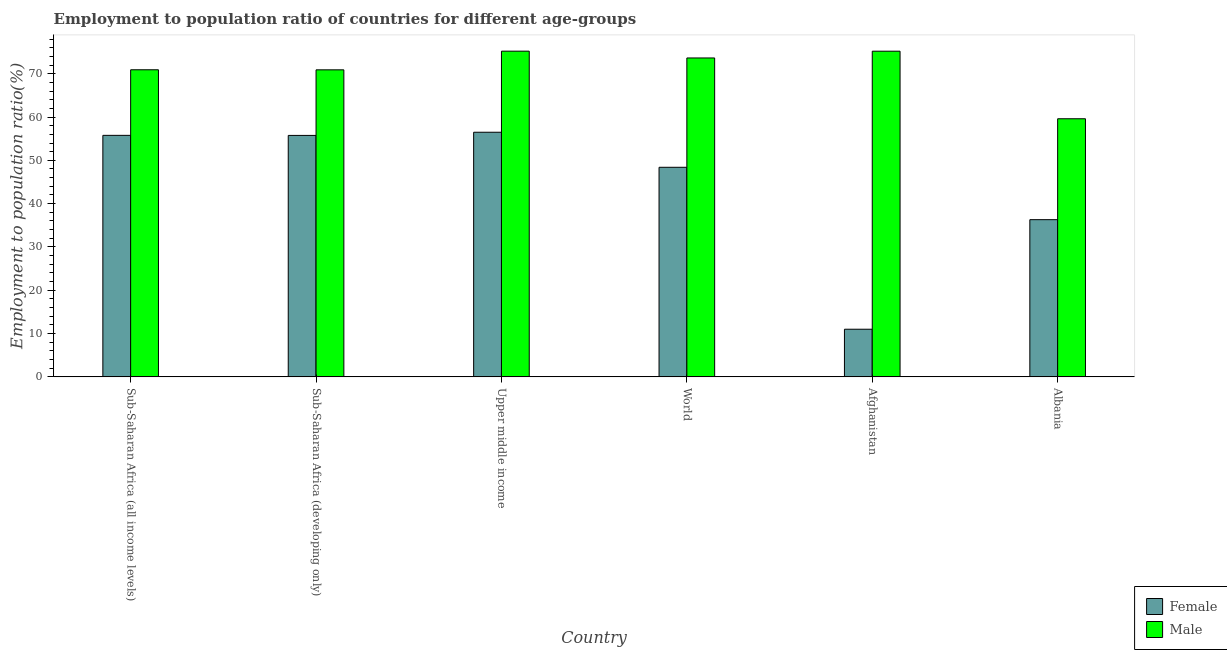How many different coloured bars are there?
Offer a very short reply. 2. Are the number of bars per tick equal to the number of legend labels?
Keep it short and to the point. Yes. Are the number of bars on each tick of the X-axis equal?
Make the answer very short. Yes. How many bars are there on the 6th tick from the right?
Ensure brevity in your answer.  2. What is the label of the 5th group of bars from the left?
Your response must be concise. Afghanistan. What is the employment to population ratio(male) in Sub-Saharan Africa (developing only)?
Provide a succinct answer. 70.89. Across all countries, what is the maximum employment to population ratio(male)?
Offer a very short reply. 75.21. Across all countries, what is the minimum employment to population ratio(female)?
Your response must be concise. 11. In which country was the employment to population ratio(female) maximum?
Your answer should be compact. Upper middle income. In which country was the employment to population ratio(male) minimum?
Give a very brief answer. Albania. What is the total employment to population ratio(male) in the graph?
Give a very brief answer. 425.45. What is the difference between the employment to population ratio(male) in Sub-Saharan Africa (developing only) and that in World?
Offer a very short reply. -2.74. What is the difference between the employment to population ratio(female) in Sub-Saharan Africa (developing only) and the employment to population ratio(male) in Upper middle income?
Give a very brief answer. -19.46. What is the average employment to population ratio(male) per country?
Your answer should be compact. 70.91. What is the difference between the employment to population ratio(female) and employment to population ratio(male) in Afghanistan?
Your answer should be very brief. -64.2. What is the ratio of the employment to population ratio(female) in Albania to that in World?
Ensure brevity in your answer.  0.75. Is the employment to population ratio(male) in Afghanistan less than that in Upper middle income?
Provide a succinct answer. Yes. What is the difference between the highest and the second highest employment to population ratio(male)?
Give a very brief answer. 0.01. What is the difference between the highest and the lowest employment to population ratio(male)?
Make the answer very short. 15.61. In how many countries, is the employment to population ratio(male) greater than the average employment to population ratio(male) taken over all countries?
Offer a terse response. 4. Is the sum of the employment to population ratio(male) in Sub-Saharan Africa (developing only) and World greater than the maximum employment to population ratio(female) across all countries?
Make the answer very short. Yes. How many bars are there?
Ensure brevity in your answer.  12. How many countries are there in the graph?
Give a very brief answer. 6. What is the difference between two consecutive major ticks on the Y-axis?
Your answer should be very brief. 10. Does the graph contain grids?
Your answer should be compact. No. Where does the legend appear in the graph?
Offer a terse response. Bottom right. What is the title of the graph?
Your answer should be compact. Employment to population ratio of countries for different age-groups. What is the label or title of the Y-axis?
Your answer should be compact. Employment to population ratio(%). What is the Employment to population ratio(%) in Female in Sub-Saharan Africa (all income levels)?
Your response must be concise. 55.77. What is the Employment to population ratio(%) in Male in Sub-Saharan Africa (all income levels)?
Keep it short and to the point. 70.91. What is the Employment to population ratio(%) of Female in Sub-Saharan Africa (developing only)?
Ensure brevity in your answer.  55.75. What is the Employment to population ratio(%) of Male in Sub-Saharan Africa (developing only)?
Your response must be concise. 70.89. What is the Employment to population ratio(%) in Female in Upper middle income?
Keep it short and to the point. 56.48. What is the Employment to population ratio(%) in Male in Upper middle income?
Keep it short and to the point. 75.21. What is the Employment to population ratio(%) of Female in World?
Ensure brevity in your answer.  48.39. What is the Employment to population ratio(%) in Male in World?
Provide a succinct answer. 73.64. What is the Employment to population ratio(%) in Male in Afghanistan?
Your answer should be very brief. 75.2. What is the Employment to population ratio(%) in Female in Albania?
Ensure brevity in your answer.  36.3. What is the Employment to population ratio(%) of Male in Albania?
Ensure brevity in your answer.  59.6. Across all countries, what is the maximum Employment to population ratio(%) in Female?
Your answer should be very brief. 56.48. Across all countries, what is the maximum Employment to population ratio(%) in Male?
Keep it short and to the point. 75.21. Across all countries, what is the minimum Employment to population ratio(%) of Male?
Make the answer very short. 59.6. What is the total Employment to population ratio(%) in Female in the graph?
Keep it short and to the point. 263.7. What is the total Employment to population ratio(%) in Male in the graph?
Provide a short and direct response. 425.45. What is the difference between the Employment to population ratio(%) of Female in Sub-Saharan Africa (all income levels) and that in Sub-Saharan Africa (developing only)?
Provide a succinct answer. 0.02. What is the difference between the Employment to population ratio(%) in Male in Sub-Saharan Africa (all income levels) and that in Sub-Saharan Africa (developing only)?
Your answer should be very brief. 0.01. What is the difference between the Employment to population ratio(%) of Female in Sub-Saharan Africa (all income levels) and that in Upper middle income?
Your answer should be very brief. -0.72. What is the difference between the Employment to population ratio(%) of Male in Sub-Saharan Africa (all income levels) and that in Upper middle income?
Provide a succinct answer. -4.3. What is the difference between the Employment to population ratio(%) in Female in Sub-Saharan Africa (all income levels) and that in World?
Ensure brevity in your answer.  7.37. What is the difference between the Employment to population ratio(%) of Male in Sub-Saharan Africa (all income levels) and that in World?
Ensure brevity in your answer.  -2.73. What is the difference between the Employment to population ratio(%) in Female in Sub-Saharan Africa (all income levels) and that in Afghanistan?
Ensure brevity in your answer.  44.77. What is the difference between the Employment to population ratio(%) of Male in Sub-Saharan Africa (all income levels) and that in Afghanistan?
Offer a very short reply. -4.29. What is the difference between the Employment to population ratio(%) of Female in Sub-Saharan Africa (all income levels) and that in Albania?
Make the answer very short. 19.47. What is the difference between the Employment to population ratio(%) of Male in Sub-Saharan Africa (all income levels) and that in Albania?
Your answer should be very brief. 11.31. What is the difference between the Employment to population ratio(%) in Female in Sub-Saharan Africa (developing only) and that in Upper middle income?
Keep it short and to the point. -0.73. What is the difference between the Employment to population ratio(%) of Male in Sub-Saharan Africa (developing only) and that in Upper middle income?
Provide a succinct answer. -4.31. What is the difference between the Employment to population ratio(%) of Female in Sub-Saharan Africa (developing only) and that in World?
Make the answer very short. 7.36. What is the difference between the Employment to population ratio(%) in Male in Sub-Saharan Africa (developing only) and that in World?
Give a very brief answer. -2.74. What is the difference between the Employment to population ratio(%) of Female in Sub-Saharan Africa (developing only) and that in Afghanistan?
Your answer should be very brief. 44.75. What is the difference between the Employment to population ratio(%) of Male in Sub-Saharan Africa (developing only) and that in Afghanistan?
Give a very brief answer. -4.31. What is the difference between the Employment to population ratio(%) of Female in Sub-Saharan Africa (developing only) and that in Albania?
Offer a very short reply. 19.45. What is the difference between the Employment to population ratio(%) in Male in Sub-Saharan Africa (developing only) and that in Albania?
Give a very brief answer. 11.29. What is the difference between the Employment to population ratio(%) in Female in Upper middle income and that in World?
Provide a short and direct response. 8.09. What is the difference between the Employment to population ratio(%) of Male in Upper middle income and that in World?
Offer a very short reply. 1.57. What is the difference between the Employment to population ratio(%) in Female in Upper middle income and that in Afghanistan?
Offer a very short reply. 45.48. What is the difference between the Employment to population ratio(%) of Male in Upper middle income and that in Afghanistan?
Provide a succinct answer. 0.01. What is the difference between the Employment to population ratio(%) in Female in Upper middle income and that in Albania?
Your response must be concise. 20.18. What is the difference between the Employment to population ratio(%) of Male in Upper middle income and that in Albania?
Ensure brevity in your answer.  15.61. What is the difference between the Employment to population ratio(%) of Female in World and that in Afghanistan?
Keep it short and to the point. 37.39. What is the difference between the Employment to population ratio(%) in Male in World and that in Afghanistan?
Your response must be concise. -1.56. What is the difference between the Employment to population ratio(%) of Female in World and that in Albania?
Ensure brevity in your answer.  12.09. What is the difference between the Employment to population ratio(%) of Male in World and that in Albania?
Provide a succinct answer. 14.04. What is the difference between the Employment to population ratio(%) of Female in Afghanistan and that in Albania?
Ensure brevity in your answer.  -25.3. What is the difference between the Employment to population ratio(%) in Male in Afghanistan and that in Albania?
Your answer should be very brief. 15.6. What is the difference between the Employment to population ratio(%) of Female in Sub-Saharan Africa (all income levels) and the Employment to population ratio(%) of Male in Sub-Saharan Africa (developing only)?
Make the answer very short. -15.13. What is the difference between the Employment to population ratio(%) of Female in Sub-Saharan Africa (all income levels) and the Employment to population ratio(%) of Male in Upper middle income?
Provide a succinct answer. -19.44. What is the difference between the Employment to population ratio(%) in Female in Sub-Saharan Africa (all income levels) and the Employment to population ratio(%) in Male in World?
Ensure brevity in your answer.  -17.87. What is the difference between the Employment to population ratio(%) of Female in Sub-Saharan Africa (all income levels) and the Employment to population ratio(%) of Male in Afghanistan?
Your answer should be compact. -19.43. What is the difference between the Employment to population ratio(%) in Female in Sub-Saharan Africa (all income levels) and the Employment to population ratio(%) in Male in Albania?
Offer a very short reply. -3.83. What is the difference between the Employment to population ratio(%) in Female in Sub-Saharan Africa (developing only) and the Employment to population ratio(%) in Male in Upper middle income?
Your response must be concise. -19.46. What is the difference between the Employment to population ratio(%) of Female in Sub-Saharan Africa (developing only) and the Employment to population ratio(%) of Male in World?
Your answer should be very brief. -17.89. What is the difference between the Employment to population ratio(%) of Female in Sub-Saharan Africa (developing only) and the Employment to population ratio(%) of Male in Afghanistan?
Your answer should be compact. -19.45. What is the difference between the Employment to population ratio(%) of Female in Sub-Saharan Africa (developing only) and the Employment to population ratio(%) of Male in Albania?
Your response must be concise. -3.85. What is the difference between the Employment to population ratio(%) in Female in Upper middle income and the Employment to population ratio(%) in Male in World?
Provide a short and direct response. -17.15. What is the difference between the Employment to population ratio(%) of Female in Upper middle income and the Employment to population ratio(%) of Male in Afghanistan?
Keep it short and to the point. -18.72. What is the difference between the Employment to population ratio(%) in Female in Upper middle income and the Employment to population ratio(%) in Male in Albania?
Offer a very short reply. -3.12. What is the difference between the Employment to population ratio(%) in Female in World and the Employment to population ratio(%) in Male in Afghanistan?
Your answer should be compact. -26.81. What is the difference between the Employment to population ratio(%) of Female in World and the Employment to population ratio(%) of Male in Albania?
Offer a terse response. -11.21. What is the difference between the Employment to population ratio(%) in Female in Afghanistan and the Employment to population ratio(%) in Male in Albania?
Keep it short and to the point. -48.6. What is the average Employment to population ratio(%) in Female per country?
Ensure brevity in your answer.  43.95. What is the average Employment to population ratio(%) of Male per country?
Make the answer very short. 70.91. What is the difference between the Employment to population ratio(%) in Female and Employment to population ratio(%) in Male in Sub-Saharan Africa (all income levels)?
Provide a short and direct response. -15.14. What is the difference between the Employment to population ratio(%) of Female and Employment to population ratio(%) of Male in Sub-Saharan Africa (developing only)?
Give a very brief answer. -15.14. What is the difference between the Employment to population ratio(%) in Female and Employment to population ratio(%) in Male in Upper middle income?
Ensure brevity in your answer.  -18.72. What is the difference between the Employment to population ratio(%) in Female and Employment to population ratio(%) in Male in World?
Keep it short and to the point. -25.24. What is the difference between the Employment to population ratio(%) in Female and Employment to population ratio(%) in Male in Afghanistan?
Provide a short and direct response. -64.2. What is the difference between the Employment to population ratio(%) of Female and Employment to population ratio(%) of Male in Albania?
Your answer should be very brief. -23.3. What is the ratio of the Employment to population ratio(%) in Female in Sub-Saharan Africa (all income levels) to that in Sub-Saharan Africa (developing only)?
Provide a short and direct response. 1. What is the ratio of the Employment to population ratio(%) in Male in Sub-Saharan Africa (all income levels) to that in Sub-Saharan Africa (developing only)?
Offer a very short reply. 1. What is the ratio of the Employment to population ratio(%) of Female in Sub-Saharan Africa (all income levels) to that in Upper middle income?
Offer a very short reply. 0.99. What is the ratio of the Employment to population ratio(%) of Male in Sub-Saharan Africa (all income levels) to that in Upper middle income?
Your answer should be very brief. 0.94. What is the ratio of the Employment to population ratio(%) in Female in Sub-Saharan Africa (all income levels) to that in World?
Offer a very short reply. 1.15. What is the ratio of the Employment to population ratio(%) of Male in Sub-Saharan Africa (all income levels) to that in World?
Your response must be concise. 0.96. What is the ratio of the Employment to population ratio(%) in Female in Sub-Saharan Africa (all income levels) to that in Afghanistan?
Give a very brief answer. 5.07. What is the ratio of the Employment to population ratio(%) in Male in Sub-Saharan Africa (all income levels) to that in Afghanistan?
Keep it short and to the point. 0.94. What is the ratio of the Employment to population ratio(%) in Female in Sub-Saharan Africa (all income levels) to that in Albania?
Ensure brevity in your answer.  1.54. What is the ratio of the Employment to population ratio(%) in Male in Sub-Saharan Africa (all income levels) to that in Albania?
Your answer should be compact. 1.19. What is the ratio of the Employment to population ratio(%) of Female in Sub-Saharan Africa (developing only) to that in Upper middle income?
Your answer should be very brief. 0.99. What is the ratio of the Employment to population ratio(%) of Male in Sub-Saharan Africa (developing only) to that in Upper middle income?
Make the answer very short. 0.94. What is the ratio of the Employment to population ratio(%) in Female in Sub-Saharan Africa (developing only) to that in World?
Your response must be concise. 1.15. What is the ratio of the Employment to population ratio(%) of Male in Sub-Saharan Africa (developing only) to that in World?
Keep it short and to the point. 0.96. What is the ratio of the Employment to population ratio(%) in Female in Sub-Saharan Africa (developing only) to that in Afghanistan?
Ensure brevity in your answer.  5.07. What is the ratio of the Employment to population ratio(%) in Male in Sub-Saharan Africa (developing only) to that in Afghanistan?
Ensure brevity in your answer.  0.94. What is the ratio of the Employment to population ratio(%) in Female in Sub-Saharan Africa (developing only) to that in Albania?
Provide a succinct answer. 1.54. What is the ratio of the Employment to population ratio(%) in Male in Sub-Saharan Africa (developing only) to that in Albania?
Your answer should be compact. 1.19. What is the ratio of the Employment to population ratio(%) in Female in Upper middle income to that in World?
Provide a short and direct response. 1.17. What is the ratio of the Employment to population ratio(%) of Male in Upper middle income to that in World?
Provide a succinct answer. 1.02. What is the ratio of the Employment to population ratio(%) in Female in Upper middle income to that in Afghanistan?
Your answer should be very brief. 5.13. What is the ratio of the Employment to population ratio(%) in Female in Upper middle income to that in Albania?
Make the answer very short. 1.56. What is the ratio of the Employment to population ratio(%) in Male in Upper middle income to that in Albania?
Give a very brief answer. 1.26. What is the ratio of the Employment to population ratio(%) of Female in World to that in Afghanistan?
Offer a very short reply. 4.4. What is the ratio of the Employment to population ratio(%) in Male in World to that in Afghanistan?
Offer a very short reply. 0.98. What is the ratio of the Employment to population ratio(%) of Female in World to that in Albania?
Make the answer very short. 1.33. What is the ratio of the Employment to population ratio(%) of Male in World to that in Albania?
Make the answer very short. 1.24. What is the ratio of the Employment to population ratio(%) in Female in Afghanistan to that in Albania?
Your answer should be compact. 0.3. What is the ratio of the Employment to population ratio(%) of Male in Afghanistan to that in Albania?
Provide a succinct answer. 1.26. What is the difference between the highest and the second highest Employment to population ratio(%) in Female?
Give a very brief answer. 0.72. What is the difference between the highest and the second highest Employment to population ratio(%) of Male?
Keep it short and to the point. 0.01. What is the difference between the highest and the lowest Employment to population ratio(%) of Female?
Offer a very short reply. 45.48. What is the difference between the highest and the lowest Employment to population ratio(%) of Male?
Provide a short and direct response. 15.61. 